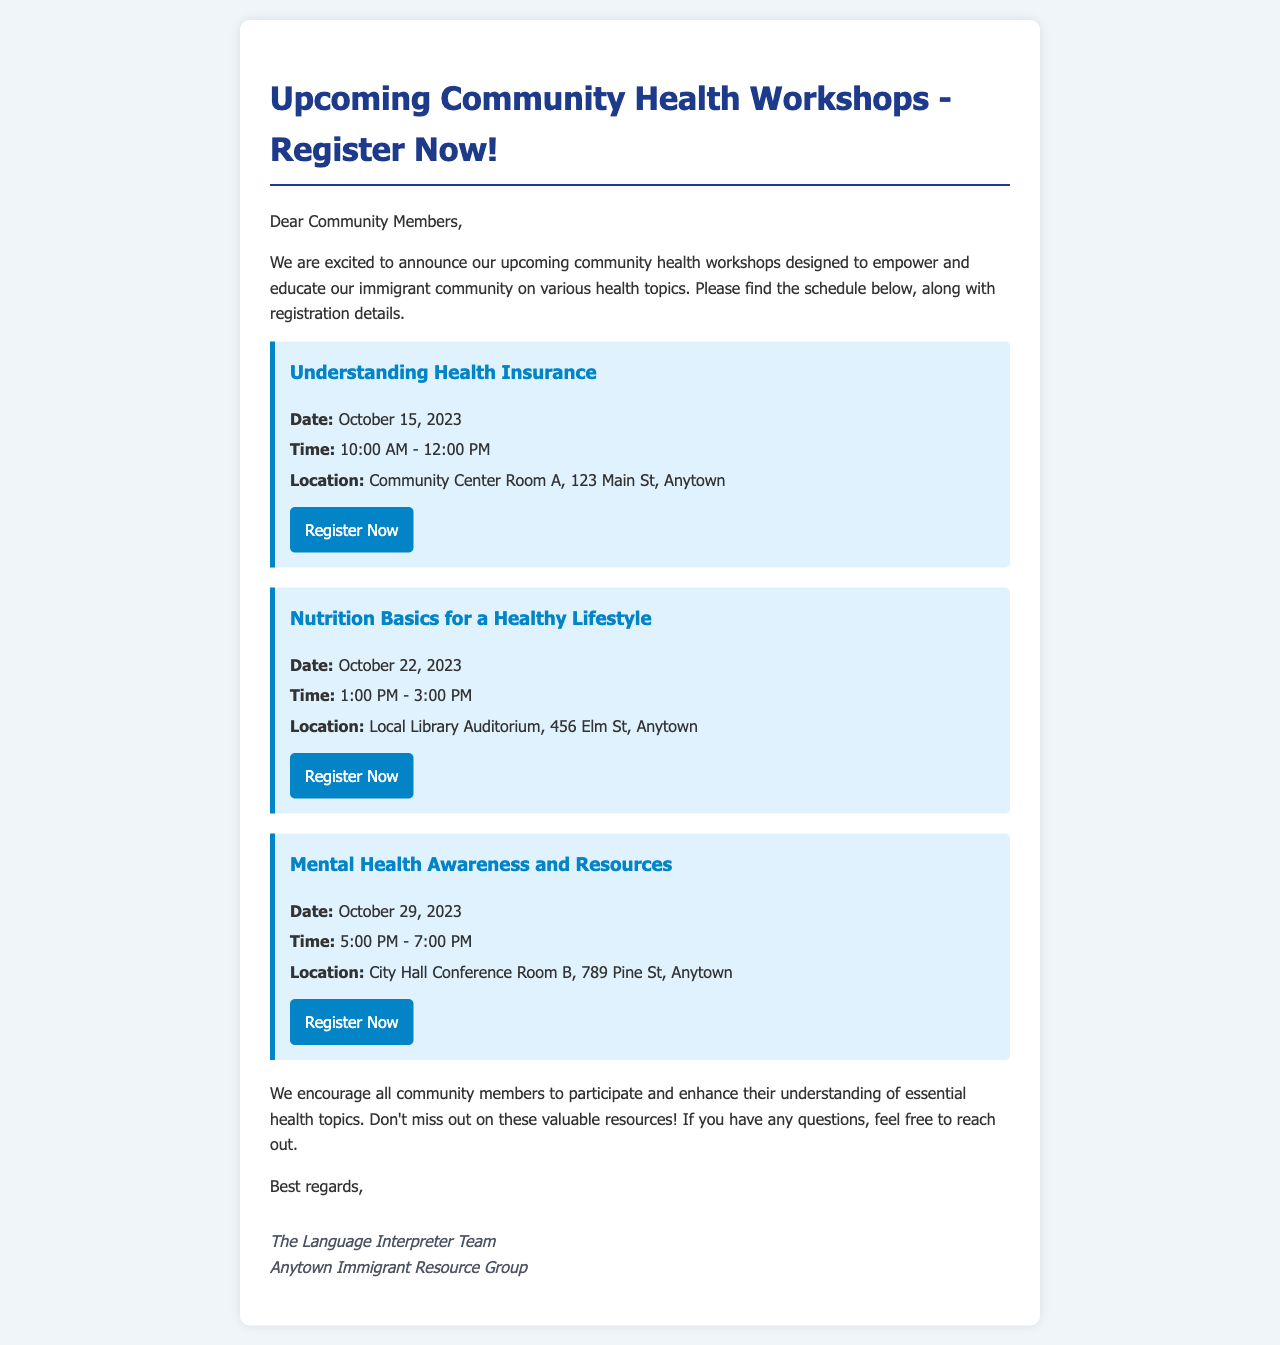What is the first workshop title? The first workshop listed in the document is "Understanding Health Insurance."
Answer: Understanding Health Insurance When is the "Nutrition Basics for a Healthy Lifestyle" workshop scheduled? This workshop is scheduled for October 22, 2023.
Answer: October 22, 2023 What time does the "Mental Health Awareness and Resources" workshop start? The workshop starts at 5:00 PM.
Answer: 5:00 PM Where is the "Understanding Health Insurance" workshop being held? This workshop will take place at Community Center Room A, 123 Main St, Anytown.
Answer: Community Center Room A, 123 Main St, Anytown How many workshops are listed in the document? The document lists three workshops.
Answer: Three What is the purpose of the workshops mentioned in the email? The purpose of the workshops is to empower and educate the immigrant community on various health topics.
Answer: Empower and educate Who is the sender of the email? The email is sent by the Language Interpreter Team at the Anytown Immigrant Resource Group.
Answer: Language Interpreter Team What can community members do if they have questions about the workshops? Community members can reach out for more information if they have questions.
Answer: Reach out What color is the button to register for the workshops? The button is a shade of blue with the color code #0284c7 and changes on hover.
Answer: Blue 